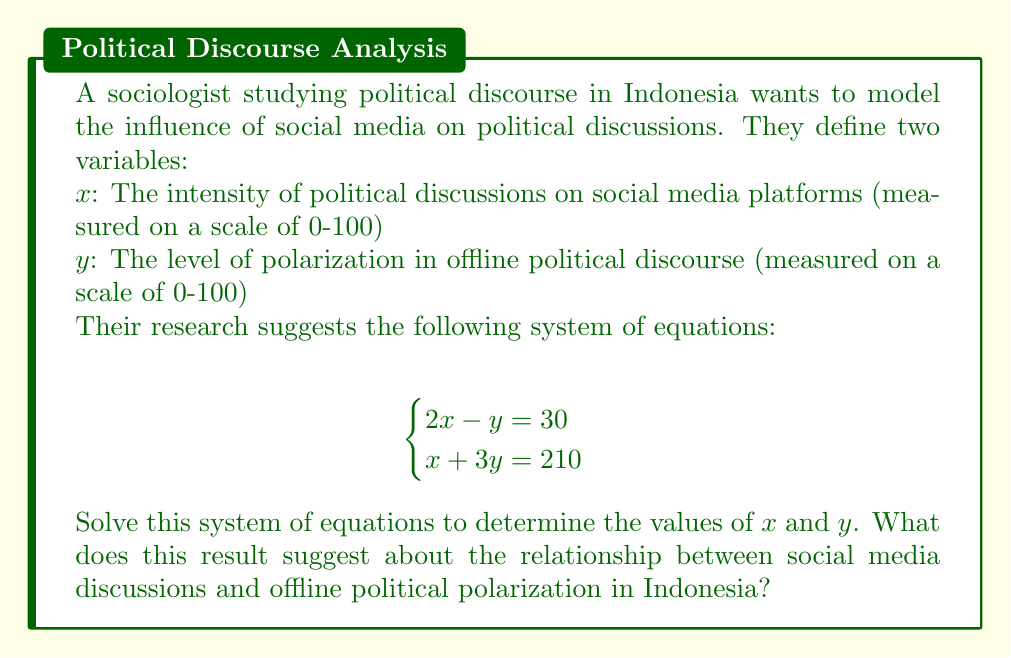Give your solution to this math problem. To solve this system of equations, we'll use the substitution method:

1) From the first equation, express $y$ in terms of $x$:
   $2x - y = 30$
   $-y = 30 - 2x$
   $y = 2x - 30$

2) Substitute this expression for $y$ into the second equation:
   $x + 3y = 210$
   $x + 3(2x - 30) = 210$
   $x + 6x - 90 = 210$
   $7x - 90 = 210$

3) Solve for $x$:
   $7x = 300$
   $x = \frac{300}{7} \approx 42.86$

4) Substitute this value of $x$ back into the equation for $y$:
   $y = 2x - 30$
   $y = 2(42.86) - 30$
   $y = 85.72 - 30 = 55.72$

5) Round to two decimal places:
   $x \approx 42.86$
   $y \approx 55.72$

This result suggests that when the intensity of political discussions on social media (x) is about 42.86 on a scale of 0-100, the level of polarization in offline political discourse (y) is about 55.72 on the same scale. This indicates a moderate level of social media political discussion corresponds to a slightly higher level of offline political polarization in Indonesia.
Answer: $x \approx 42.86$, $y \approx 55.72$ 